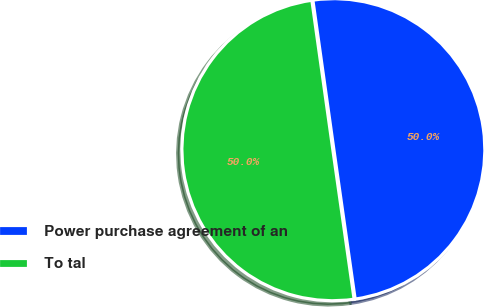Convert chart. <chart><loc_0><loc_0><loc_500><loc_500><pie_chart><fcel>Power purchase agreement of an<fcel>To tal<nl><fcel>49.97%<fcel>50.03%<nl></chart> 